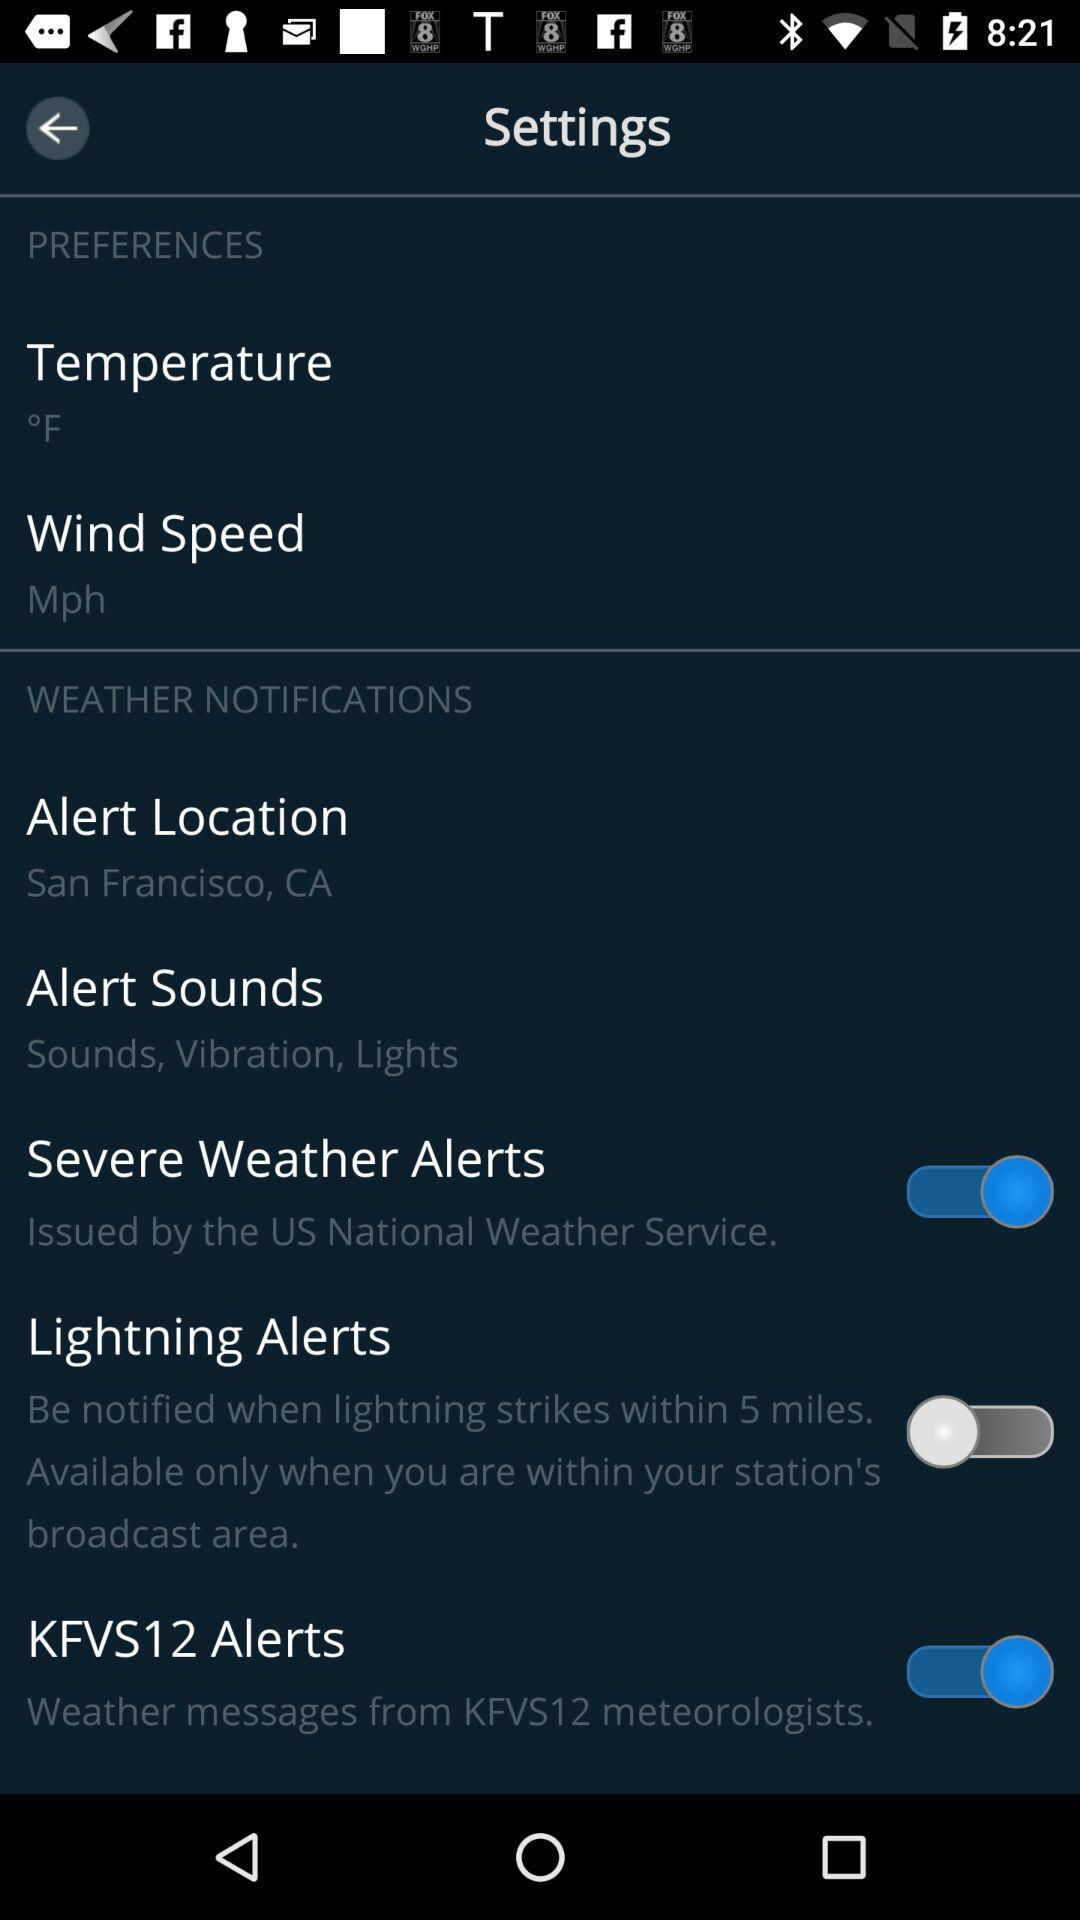What is the unit of wind speed? The unit of wind speed is "Mph". 